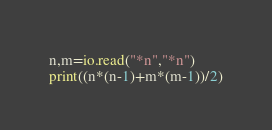Convert code to text. <code><loc_0><loc_0><loc_500><loc_500><_Lua_>n,m=io.read("*n","*n")
print((n*(n-1)+m*(m-1))/2)</code> 